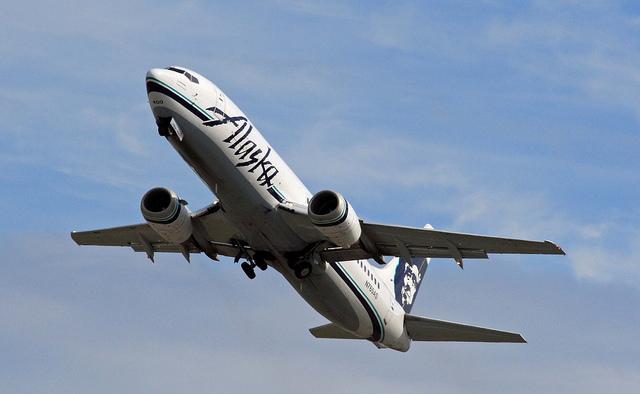What country is this plane from?
Answer briefly. Usa. What State is written on the side of the plane?
Answer briefly. Alaska. Is the plane landing?
Quick response, please. No. How many engines does the plane have?
Answer briefly. 2. What main color is the plane?
Give a very brief answer. White. Is this an airport?
Answer briefly. No. Is the plane flying?
Short answer required. Yes. 